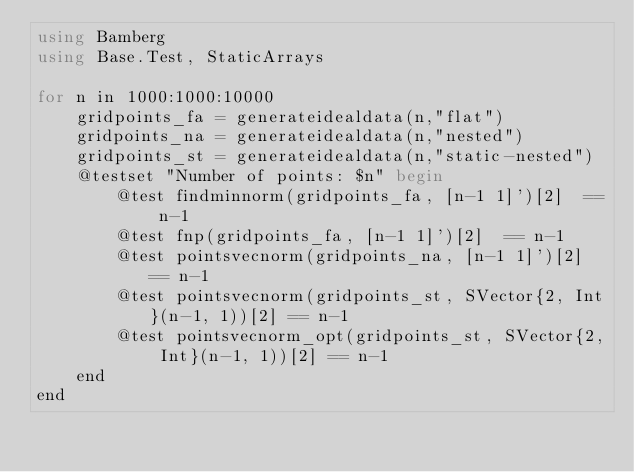<code> <loc_0><loc_0><loc_500><loc_500><_Julia_>using Bamberg
using Base.Test, StaticArrays

for n in 1000:1000:10000
    gridpoints_fa = generateidealdata(n,"flat")    
    gridpoints_na = generateidealdata(n,"nested")
    gridpoints_st = generateidealdata(n,"static-nested")
    @testset "Number of points: $n" begin
        @test findminnorm(gridpoints_fa, [n-1 1]')[2]  == n-1
        @test fnp(gridpoints_fa, [n-1 1]')[2]  == n-1
        @test pointsvecnorm(gridpoints_na, [n-1 1]')[2] == n-1
        @test pointsvecnorm(gridpoints_st, SVector{2, Int}(n-1, 1))[2] == n-1
        @test pointsvecnorm_opt(gridpoints_st, SVector{2, Int}(n-1, 1))[2] == n-1
    end
end</code> 